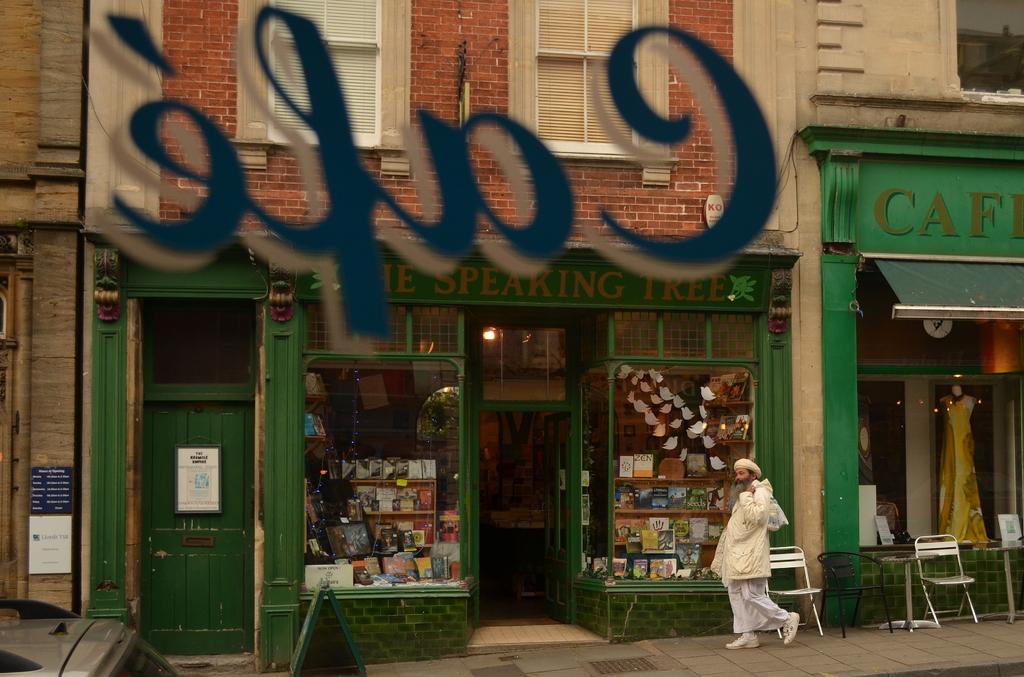What is the word right of the door of the green store front?
Ensure brevity in your answer.  Cafe. What is the name of the shop opposite the cafe?
Give a very brief answer. The speaking tree. 